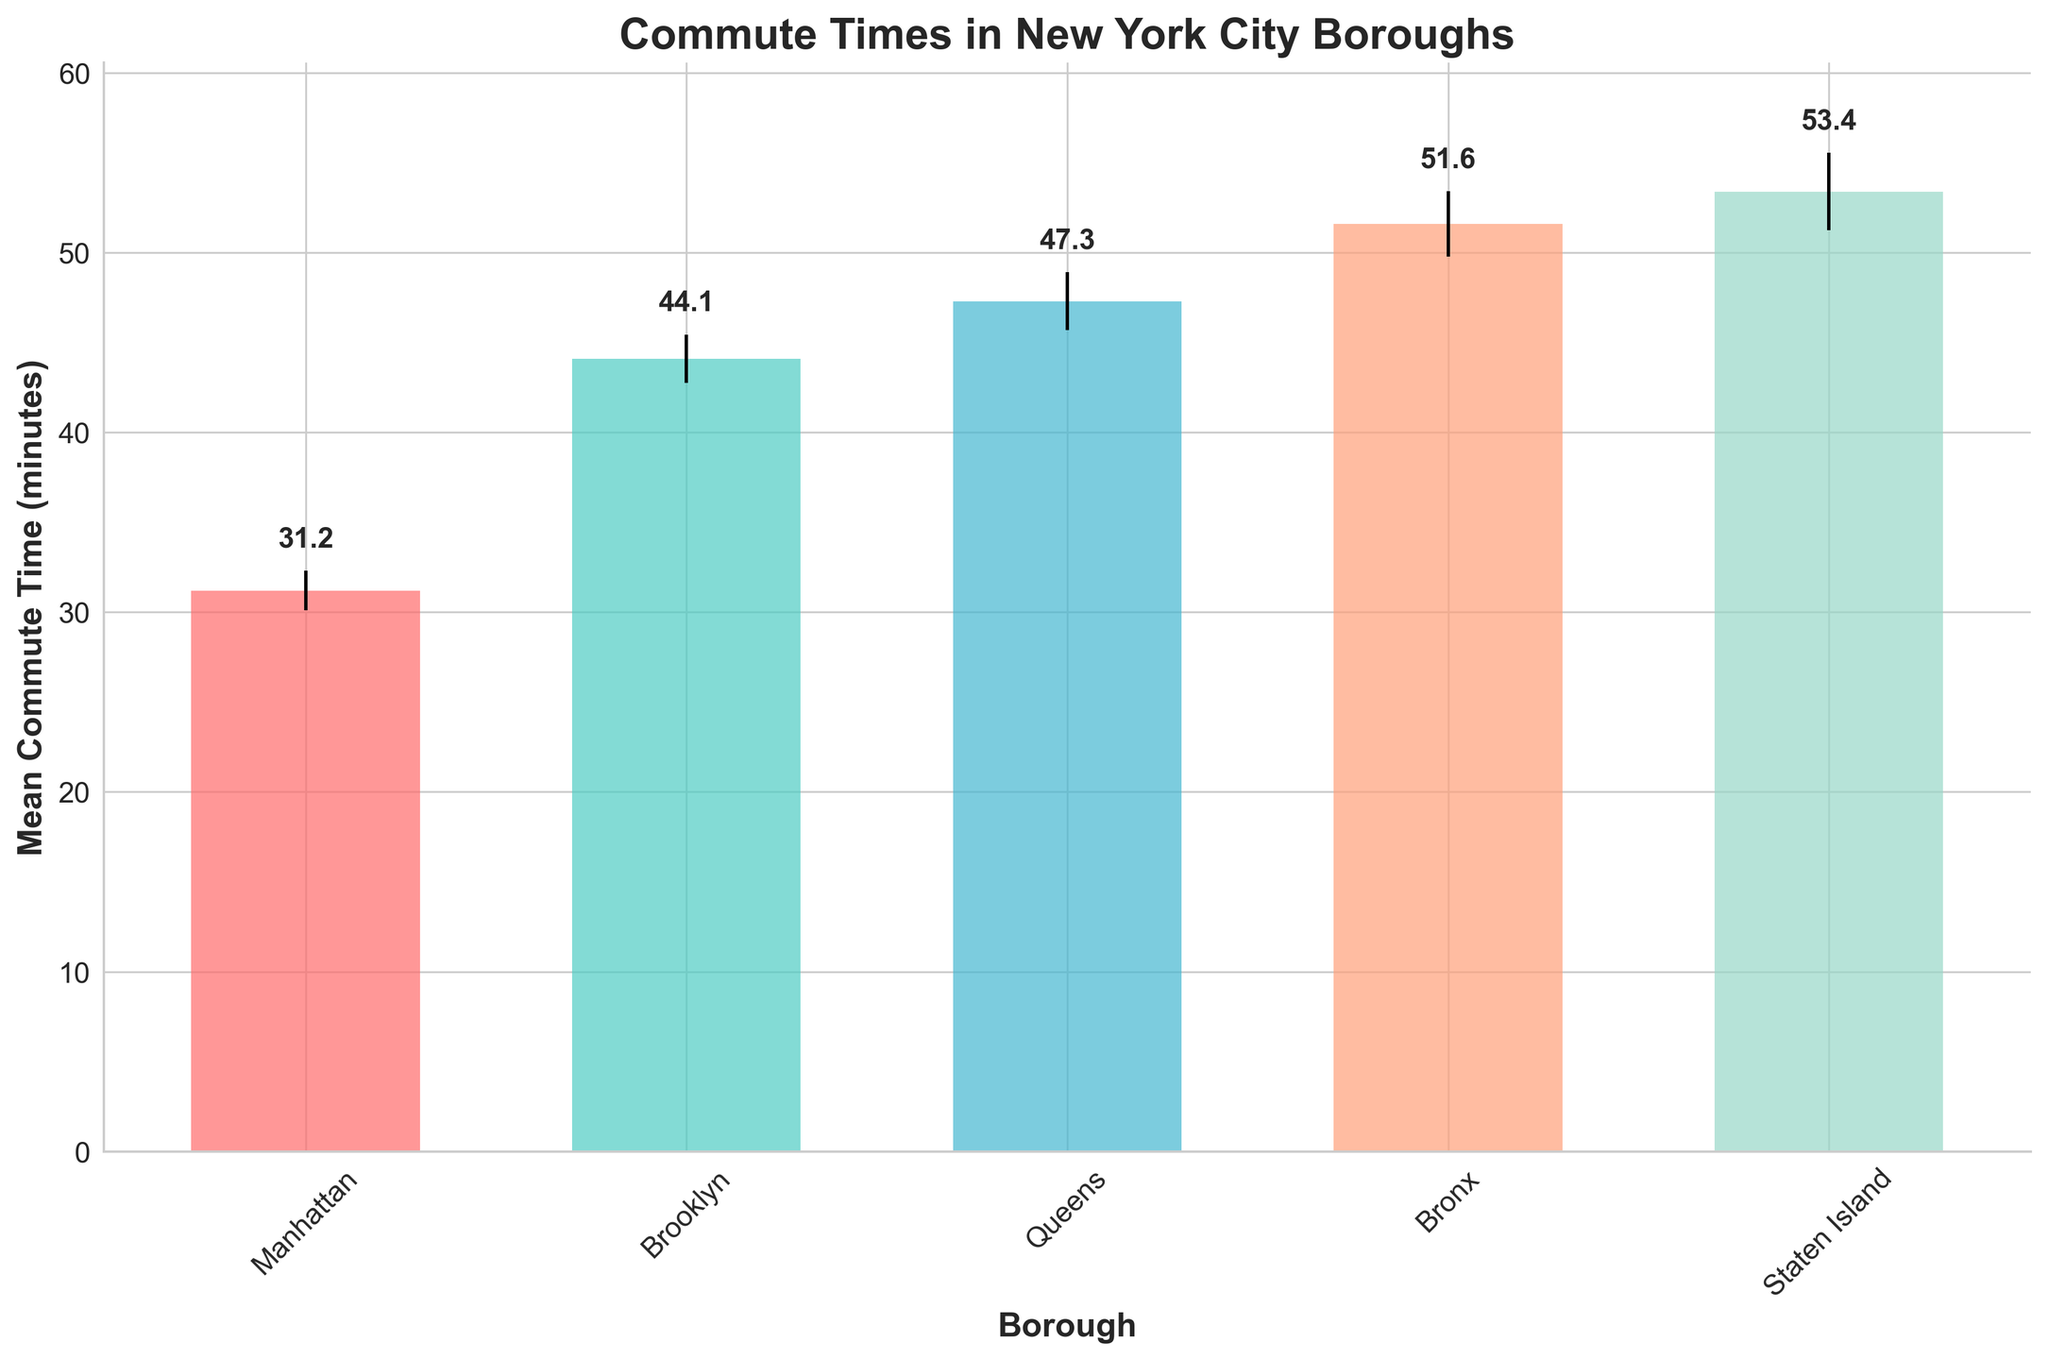what is the title of the plot? The title of the plot is displayed at the top center of the figure. It summarizes what the plot is about.
Answer: Commute Times in New York City Boroughs what is the mean commute time for Brooklyn? Look at the bar labeled "Brooklyn" and the number displayed above the bar.
Answer: 44.1 minutes which borough has the highest mean commute time? Compare the heights of all the bars to find the tallest one. Previously, the bar with the tallest height indicates the highest mean commute time.
Answer: Staten Island how are the boroughs ordered in the plot? Check the labels on the x-axis. The order is from left to right.
Answer: Manhattan, Brooklyn, Queens, Bronx, Staten Island what is the mean commute time for Queens plus the mean commute time for the Bronx? Add the values of the mean commute times for Queens and the Bronx. The mean commute times are 47.3 and 51.6 respectively. So, 47.3 + 51.6 = 98.9 minutes.
Answer: 98.9 minutes what is the difference in commute times between Staten Island and the borough with the shortest mean commute time? Identify the borough with the shortest mean commute time (Manhattan), and subtract its mean commute time from Staten Island's mean. Staten Island has 53.4 minutes and Manhattan has 31.2 minutes. So, 53.4 - 31.2 = 22.2 minutes.
Answer: 22.2 minutes which boroughs have mean commute times greater than 45 minutes? Compare all the mean commute times to see which boroughs have values greater than 45. Queens, Bronx, and Staten Island have mean commute times of 47.3, 51.6, and 53.4 minutes respectively, all greater than the 45-minute mark.
Answer: Queens, Bronx, Staten Island what does the length of the error bars represent? The error bars extend from the top of each bar. The lengths represent the standard error, or the standard deviation of the means divided by the square root of the sample size (n). It provides a visual representation of the confidence intervals for the mean commute times.
Answer: Standard error which borough has the smallest error bar? Compare the lengths of all the error bars to find the shortest one. The bar for Manhattan has the smallest error bar.
Answer: Manhattan how does the mean commute time for Bronx compare with the mean commute time for Brooklyn? The bar for Bronx represents a mean commute time of 51.6 minutes, while the bar for Brooklyn is 44.1 minutes. Since 51.6 is greater than 44.1, Bronx has a longer mean commute time compared to Brooklyn.
Answer: Bronx has a longer commute time 